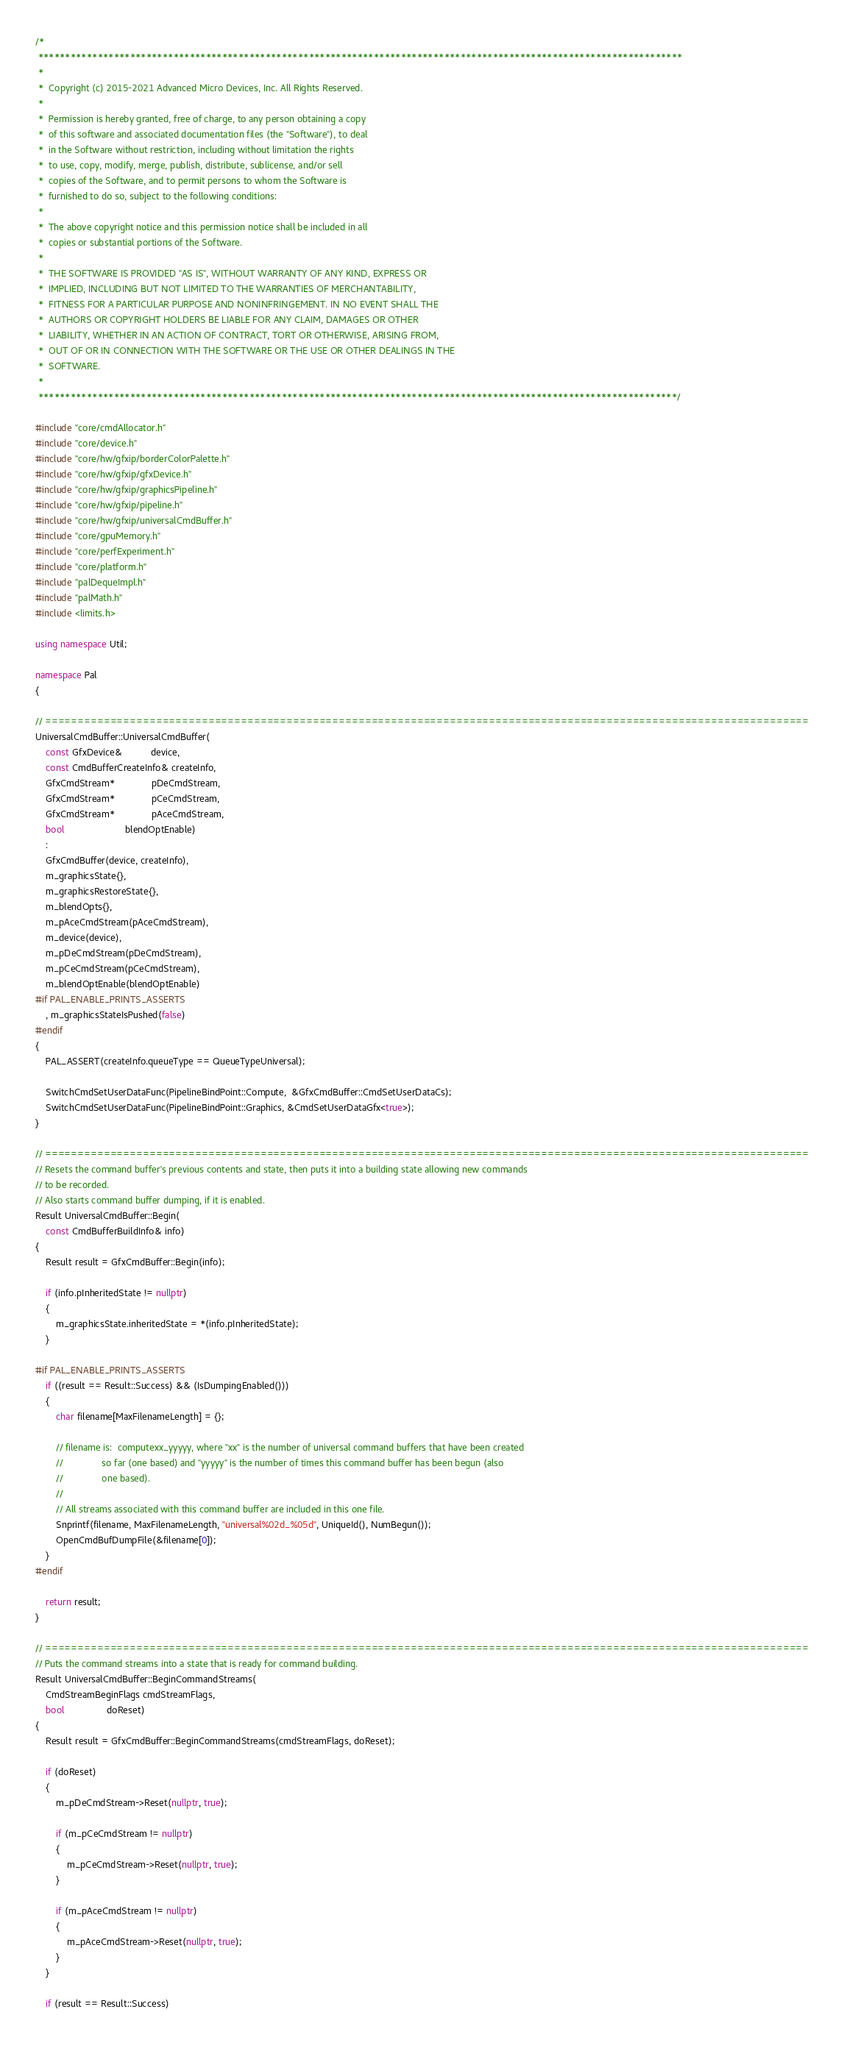<code> <loc_0><loc_0><loc_500><loc_500><_C++_>/*
 ***********************************************************************************************************************
 *
 *  Copyright (c) 2015-2021 Advanced Micro Devices, Inc. All Rights Reserved.
 *
 *  Permission is hereby granted, free of charge, to any person obtaining a copy
 *  of this software and associated documentation files (the "Software"), to deal
 *  in the Software without restriction, including without limitation the rights
 *  to use, copy, modify, merge, publish, distribute, sublicense, and/or sell
 *  copies of the Software, and to permit persons to whom the Software is
 *  furnished to do so, subject to the following conditions:
 *
 *  The above copyright notice and this permission notice shall be included in all
 *  copies or substantial portions of the Software.
 *
 *  THE SOFTWARE IS PROVIDED "AS IS", WITHOUT WARRANTY OF ANY KIND, EXPRESS OR
 *  IMPLIED, INCLUDING BUT NOT LIMITED TO THE WARRANTIES OF MERCHANTABILITY,
 *  FITNESS FOR A PARTICULAR PURPOSE AND NONINFRINGEMENT. IN NO EVENT SHALL THE
 *  AUTHORS OR COPYRIGHT HOLDERS BE LIABLE FOR ANY CLAIM, DAMAGES OR OTHER
 *  LIABILITY, WHETHER IN AN ACTION OF CONTRACT, TORT OR OTHERWISE, ARISING FROM,
 *  OUT OF OR IN CONNECTION WITH THE SOFTWARE OR THE USE OR OTHER DEALINGS IN THE
 *  SOFTWARE.
 *
 **********************************************************************************************************************/

#include "core/cmdAllocator.h"
#include "core/device.h"
#include "core/hw/gfxip/borderColorPalette.h"
#include "core/hw/gfxip/gfxDevice.h"
#include "core/hw/gfxip/graphicsPipeline.h"
#include "core/hw/gfxip/pipeline.h"
#include "core/hw/gfxip/universalCmdBuffer.h"
#include "core/gpuMemory.h"
#include "core/perfExperiment.h"
#include "core/platform.h"
#include "palDequeImpl.h"
#include "palMath.h"
#include <limits.h>

using namespace Util;

namespace Pal
{

// =====================================================================================================================
UniversalCmdBuffer::UniversalCmdBuffer(
    const GfxDevice&           device,
    const CmdBufferCreateInfo& createInfo,
    GfxCmdStream*              pDeCmdStream,
    GfxCmdStream*              pCeCmdStream,
    GfxCmdStream*              pAceCmdStream,
    bool                       blendOptEnable)
    :
    GfxCmdBuffer(device, createInfo),
    m_graphicsState{},
    m_graphicsRestoreState{},
    m_blendOpts{},
    m_pAceCmdStream(pAceCmdStream),
    m_device(device),
    m_pDeCmdStream(pDeCmdStream),
    m_pCeCmdStream(pCeCmdStream),
    m_blendOptEnable(blendOptEnable)
#if PAL_ENABLE_PRINTS_ASSERTS
    , m_graphicsStateIsPushed(false)
#endif
{
    PAL_ASSERT(createInfo.queueType == QueueTypeUniversal);

    SwitchCmdSetUserDataFunc(PipelineBindPoint::Compute,  &GfxCmdBuffer::CmdSetUserDataCs);
    SwitchCmdSetUserDataFunc(PipelineBindPoint::Graphics, &CmdSetUserDataGfx<true>);
}

// =====================================================================================================================
// Resets the command buffer's previous contents and state, then puts it into a building state allowing new commands
// to be recorded.
// Also starts command buffer dumping, if it is enabled.
Result UniversalCmdBuffer::Begin(
    const CmdBufferBuildInfo& info)
{
    Result result = GfxCmdBuffer::Begin(info);

    if (info.pInheritedState != nullptr)
    {
        m_graphicsState.inheritedState = *(info.pInheritedState);
    }

#if PAL_ENABLE_PRINTS_ASSERTS
    if ((result == Result::Success) && (IsDumpingEnabled()))
    {
        char filename[MaxFilenameLength] = {};

        // filename is:  computexx_yyyyy, where "xx" is the number of universal command buffers that have been created
        //               so far (one based) and "yyyyy" is the number of times this command buffer has been begun (also
        //               one based).
        //
        // All streams associated with this command buffer are included in this one file.
        Snprintf(filename, MaxFilenameLength, "universal%02d_%05d", UniqueId(), NumBegun());
        OpenCmdBufDumpFile(&filename[0]);
    }
#endif

    return result;
}

// =====================================================================================================================
// Puts the command streams into a state that is ready for command building.
Result UniversalCmdBuffer::BeginCommandStreams(
    CmdStreamBeginFlags cmdStreamFlags,
    bool                doReset)
{
    Result result = GfxCmdBuffer::BeginCommandStreams(cmdStreamFlags, doReset);

    if (doReset)
    {
        m_pDeCmdStream->Reset(nullptr, true);

        if (m_pCeCmdStream != nullptr)
        {
            m_pCeCmdStream->Reset(nullptr, true);
        }

        if (m_pAceCmdStream != nullptr)
        {
            m_pAceCmdStream->Reset(nullptr, true);
        }
    }

    if (result == Result::Success)</code> 